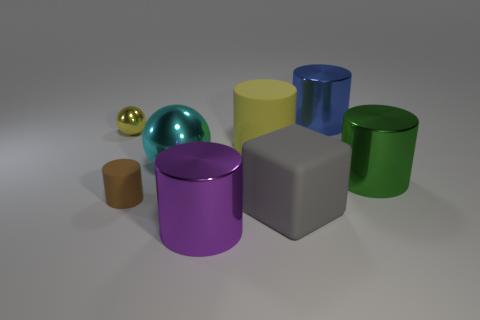There is a large matte object that is behind the small brown matte object; what shape is it?
Your answer should be very brief. Cylinder. Does the small cylinder have the same material as the ball that is in front of the yellow matte cylinder?
Offer a terse response. No. Does the purple thing have the same shape as the big green metallic object?
Make the answer very short. Yes. What is the material of the large yellow object that is the same shape as the large blue metallic thing?
Your response must be concise. Rubber. There is a large cylinder that is both in front of the big cyan metallic thing and left of the big blue metallic cylinder; what color is it?
Your response must be concise. Purple. The small matte cylinder is what color?
Offer a terse response. Brown. There is a cylinder that is the same color as the small ball; what is its material?
Give a very brief answer. Rubber. Is there a cyan metallic thing that has the same shape as the tiny yellow metal thing?
Keep it short and to the point. Yes. There is a matte cylinder that is on the left side of the cyan shiny sphere; what is its size?
Keep it short and to the point. Small. There is a blue object that is the same size as the green thing; what is its material?
Your response must be concise. Metal. 